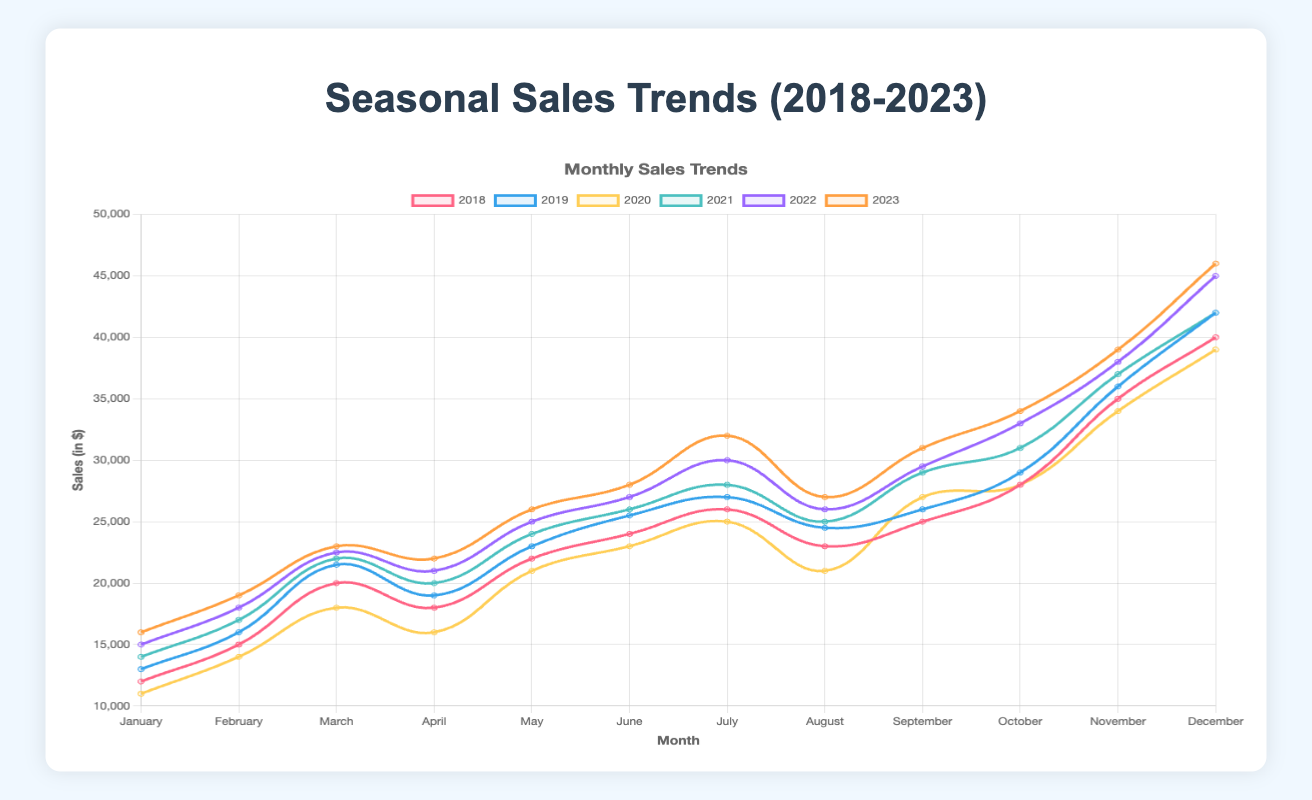Which year had the lowest sales in January? By visually inspecting the trend lines on the plot, we see that the line representing 2020 is the lowest around January with a value of $11,000.
Answer: 2020 Which year saw the highest sales in December? By checking the end of each year's line plot, the line for 2023 peaks the highest in December, at $46,000.
Answer: 2023 How does the sales trend for Q2 in 2020 compare to Q2 in 2021? For 2020, the Q2 sales were April: $16,000, May: $21,000, June: $23,000. For 2021, the Q2 sales were April: $20,000, May: $24,000, June: $26,000. All values in 2021 are higher than those in 2020.
Answer: Higher in 2021 What is the average monthly sales for 2018? Add the 12 monthly sales values for 2018 (12000 + 15000 + 20000 + 18000 + 22000 + 24000 + 26000 + 23000 + 25000 + 28000 + 35000 + 40000 = 298000), then divide by 12 to get the average. 298000 / 12 = $24,833.33
Answer: $24,833.33 Which quarter typically has the highest sales across all years? Visually each year’s line plots show a peak in Q4, specifically in December.
Answer: Q4 What is the total sales difference between February 2019 and February 2020? February 2019 sales were $16,000, and February 2020 sales were $14,000. The difference is 16000 - 14000 = $2,000.
Answer: $2,000 Which year had the most consistent sales growth in Q3? Consistent growth means lesser month-to-month variability. Reviewing July to September for each year, 2019 (27000 to 26000) shows the least fluctuation.
Answer: 2019 What was the percentage increase in November sales from 2018 to 2023? Sales in November 2018 were $35,000, and in 2023 were $39,000. The percentage increase is ((39000 - 35000) / 35000) * 100 = 11.43%.
Answer: 11.43% In which year did sales drop the most from one month to another in Q3? Looking at month-to-month sales changes, 2020 had significant drops, such as from July ($25,000) to August ($21,000), a drop of $4,000.
Answer: 2020 When comparing March sales, which two years have the largest difference? Reviewing March values across years, 2023 ($23,000) and 2020 ($18,000) have the largest difference. Difference = 23000 - 18000 = $5,000.
Answer: 2023 and 2020 